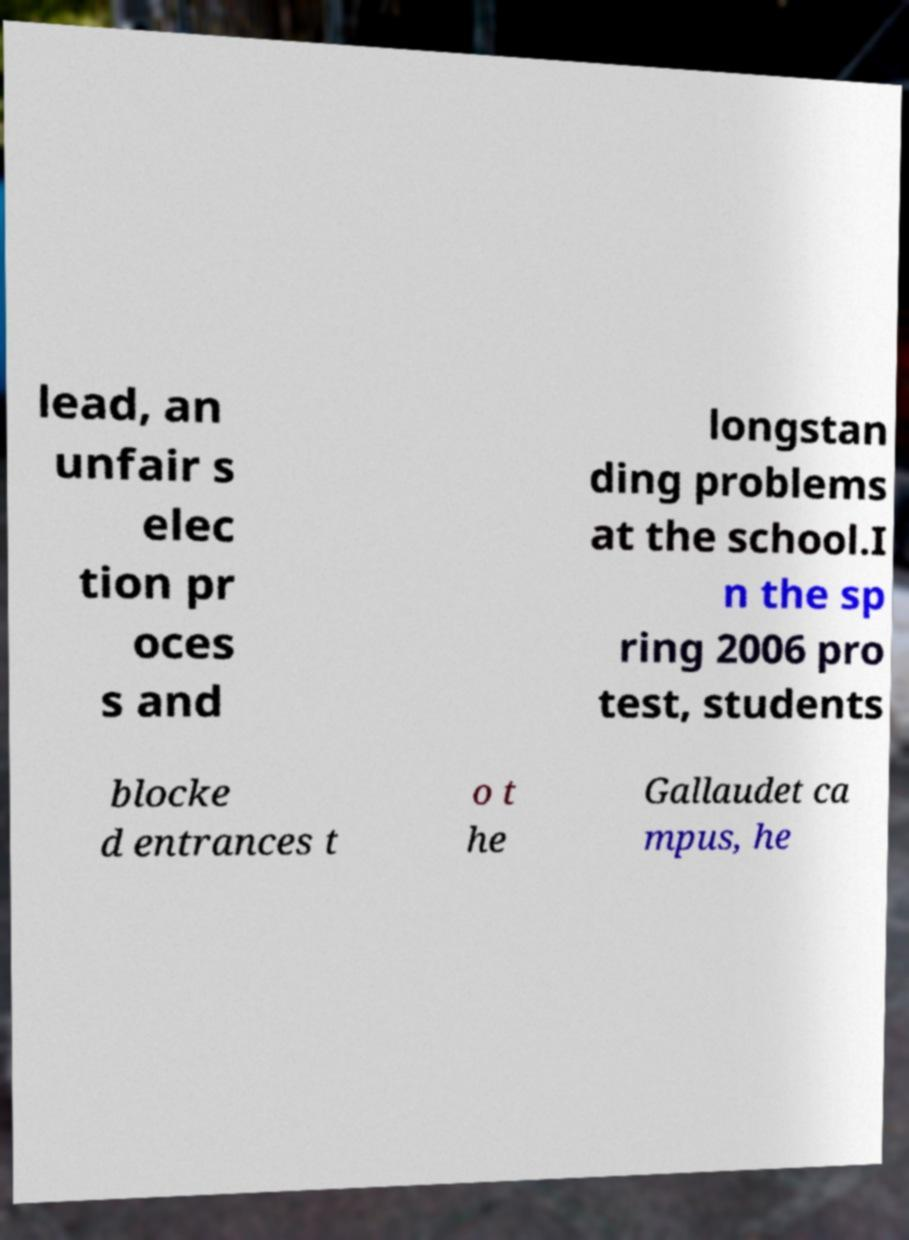Please read and relay the text visible in this image. What does it say? lead, an unfair s elec tion pr oces s and longstan ding problems at the school.I n the sp ring 2006 pro test, students blocke d entrances t o t he Gallaudet ca mpus, he 